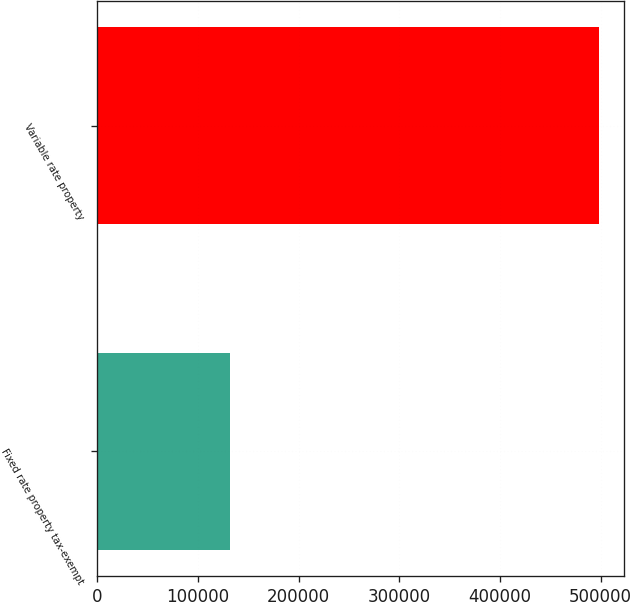Convert chart to OTSL. <chart><loc_0><loc_0><loc_500><loc_500><bar_chart><fcel>Fixed rate property tax-exempt<fcel>Variable rate property<nl><fcel>131530<fcel>497969<nl></chart> 